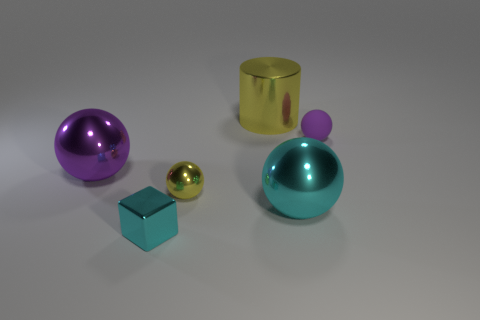Can you describe the light and shadows in the image? The image exhibits a soft and diffuse lighting scenario. Shadows are cast gently to the right of the objects, suggesting the primary light source is coming from the left. The shadows' soft edges indicate the light source is not harsh, providing an evenly lit scene with soft contrasts. 